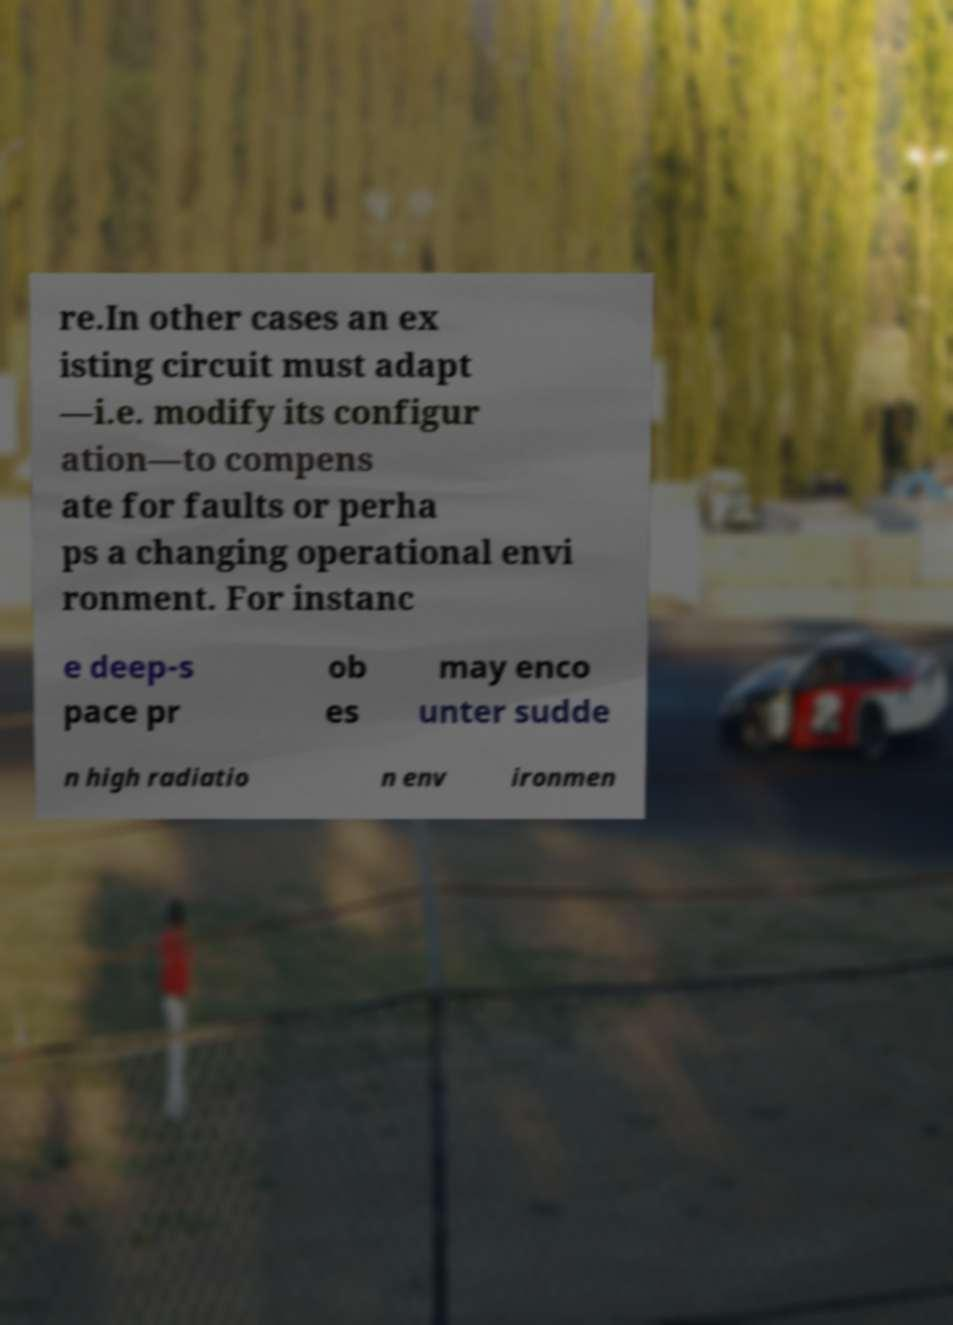Could you assist in decoding the text presented in this image and type it out clearly? re.In other cases an ex isting circuit must adapt —i.e. modify its configur ation—to compens ate for faults or perha ps a changing operational envi ronment. For instanc e deep-s pace pr ob es may enco unter sudde n high radiatio n env ironmen 